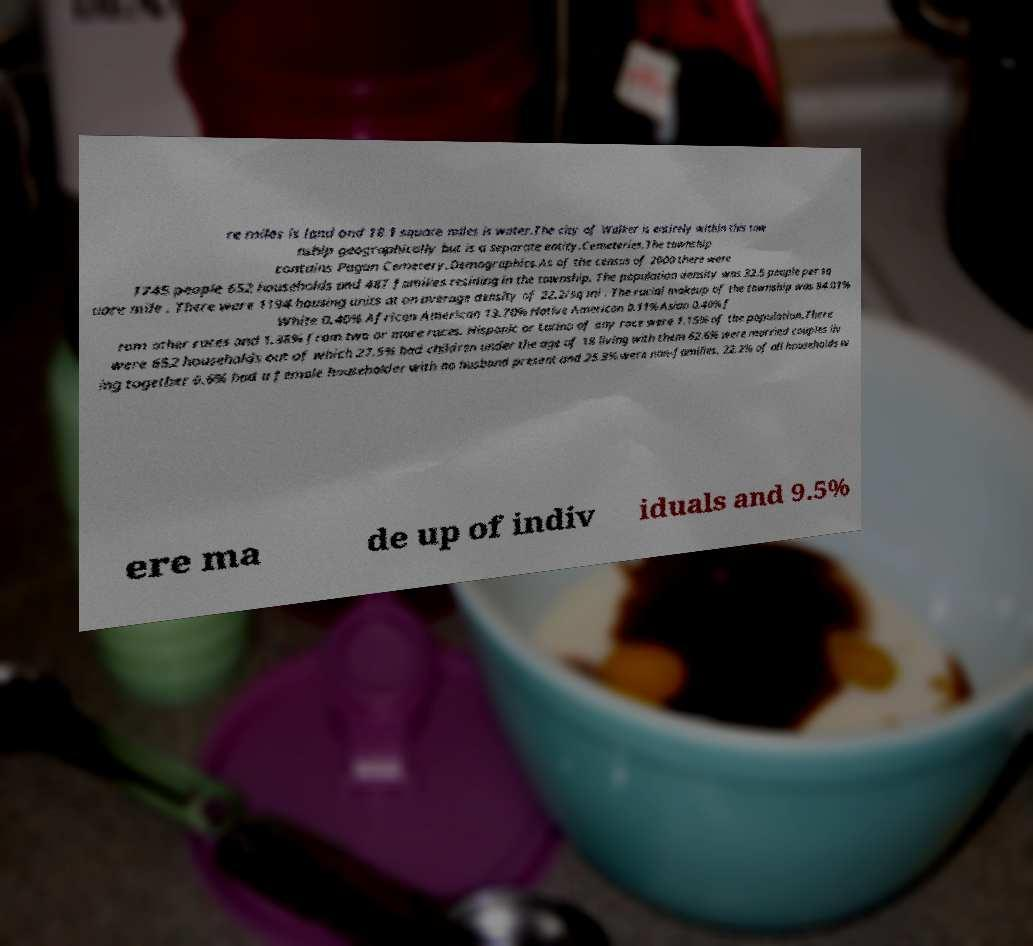What messages or text are displayed in this image? I need them in a readable, typed format. re miles is land and 18.1 square miles is water.The city of Walker is entirely within this tow nship geographically but is a separate entity.Cemeteries.The township contains Pagan Cemetery.Demographics.As of the census of 2000 there were 1745 people 652 households and 487 families residing in the township. The population density was 32.5 people per sq uare mile . There were 1194 housing units at an average density of 22.2/sq mi . The racial makeup of the township was 84.01% White 0.40% African American 13.70% Native American 0.11% Asian 0.40% f rom other races and 1.38% from two or more races. Hispanic or Latino of any race were 1.15% of the population.There were 652 households out of which 27.5% had children under the age of 18 living with them 62.6% were married couples liv ing together 6.6% had a female householder with no husband present and 25.3% were non-families. 22.2% of all households w ere ma de up of indiv iduals and 9.5% 